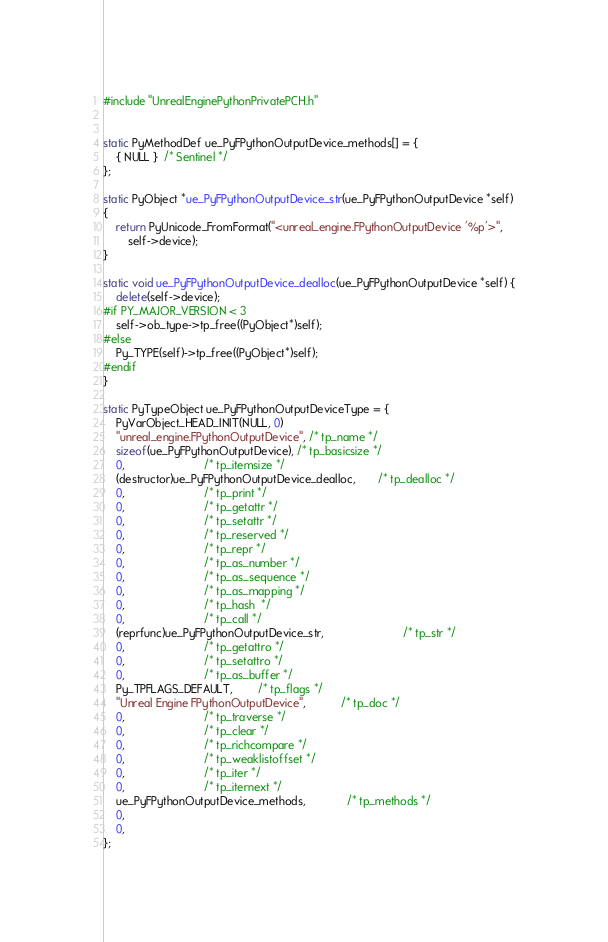<code> <loc_0><loc_0><loc_500><loc_500><_C++_>#include "UnrealEnginePythonPrivatePCH.h"


static PyMethodDef ue_PyFPythonOutputDevice_methods[] = {
	{ NULL }  /* Sentinel */
};

static PyObject *ue_PyFPythonOutputDevice_str(ue_PyFPythonOutputDevice *self)
{
	return PyUnicode_FromFormat("<unreal_engine.FPythonOutputDevice '%p'>",
		self->device);
}

static void ue_PyFPythonOutputDevice_dealloc(ue_PyFPythonOutputDevice *self) {
	delete(self->device);
#if PY_MAJOR_VERSION < 3
	self->ob_type->tp_free((PyObject*)self);
#else
	Py_TYPE(self)->tp_free((PyObject*)self);
#endif
}

static PyTypeObject ue_PyFPythonOutputDeviceType = {
	PyVarObject_HEAD_INIT(NULL, 0)
	"unreal_engine.FPythonOutputDevice", /* tp_name */
	sizeof(ue_PyFPythonOutputDevice), /* tp_basicsize */
	0,                         /* tp_itemsize */
	(destructor)ue_PyFPythonOutputDevice_dealloc,       /* tp_dealloc */
	0,                         /* tp_print */
	0,                         /* tp_getattr */
	0,                         /* tp_setattr */
	0,                         /* tp_reserved */
	0,                         /* tp_repr */
	0,                         /* tp_as_number */
	0,                         /* tp_as_sequence */
	0,                         /* tp_as_mapping */
	0,                         /* tp_hash  */
	0,                         /* tp_call */
	(reprfunc)ue_PyFPythonOutputDevice_str,                         /* tp_str */
	0,                         /* tp_getattro */
	0,                         /* tp_setattro */
	0,                         /* tp_as_buffer */
	Py_TPFLAGS_DEFAULT,        /* tp_flags */
	"Unreal Engine FPythonOutputDevice",           /* tp_doc */
	0,                         /* tp_traverse */
	0,                         /* tp_clear */
	0,                         /* tp_richcompare */
	0,                         /* tp_weaklistoffset */
	0,                         /* tp_iter */
	0,                         /* tp_iternext */
	ue_PyFPythonOutputDevice_methods,             /* tp_methods */
	0,
	0,
};
</code> 